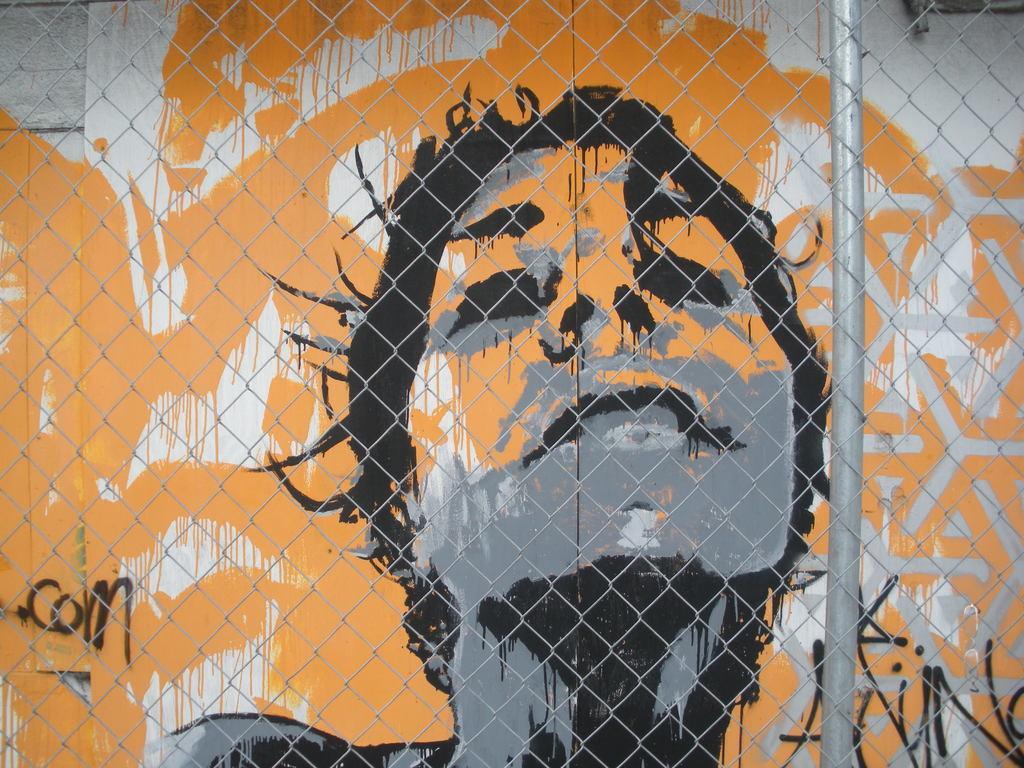Please provide a concise description of this image. In this image we can see painting on the wall and fence. 